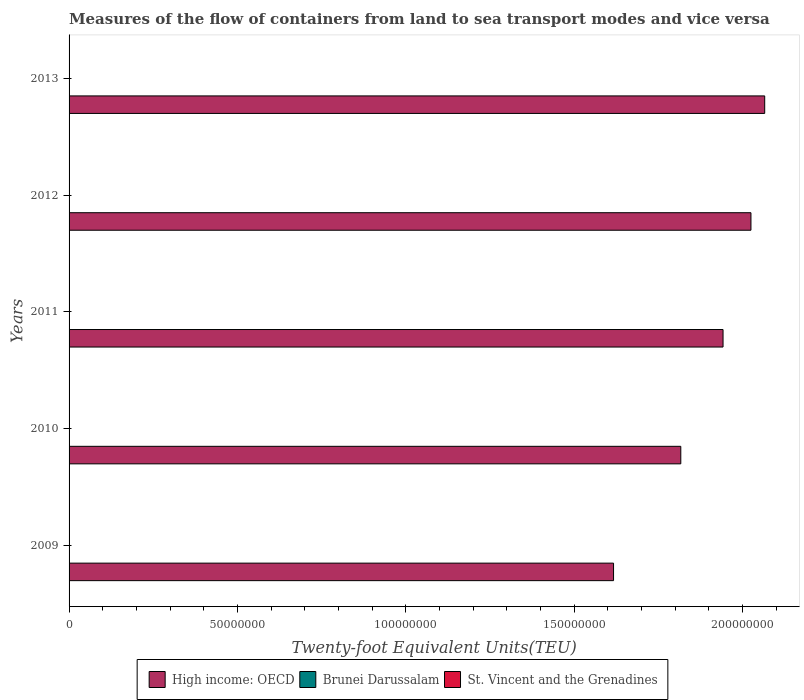How many different coloured bars are there?
Offer a terse response. 3. How many groups of bars are there?
Offer a terse response. 5. Are the number of bars per tick equal to the number of legend labels?
Make the answer very short. Yes. What is the label of the 4th group of bars from the top?
Your response must be concise. 2010. What is the container port traffic in Brunei Darussalam in 2009?
Provide a short and direct response. 8.56e+04. Across all years, what is the maximum container port traffic in St. Vincent and the Grenadines?
Offer a terse response. 2.31e+04. Across all years, what is the minimum container port traffic in High income: OECD?
Offer a very short reply. 1.62e+08. In which year was the container port traffic in St. Vincent and the Grenadines maximum?
Give a very brief answer. 2013. In which year was the container port traffic in High income: OECD minimum?
Offer a terse response. 2009. What is the total container port traffic in St. Vincent and the Grenadines in the graph?
Give a very brief answer. 9.96e+04. What is the difference between the container port traffic in St. Vincent and the Grenadines in 2009 and that in 2010?
Offer a terse response. -2614.32. What is the difference between the container port traffic in High income: OECD in 2010 and the container port traffic in Brunei Darussalam in 2011?
Provide a short and direct response. 1.82e+08. What is the average container port traffic in St. Vincent and the Grenadines per year?
Your answer should be compact. 1.99e+04. In the year 2009, what is the difference between the container port traffic in Brunei Darussalam and container port traffic in High income: OECD?
Offer a very short reply. -1.62e+08. In how many years, is the container port traffic in St. Vincent and the Grenadines greater than 30000000 TEU?
Provide a succinct answer. 0. What is the ratio of the container port traffic in High income: OECD in 2011 to that in 2013?
Keep it short and to the point. 0.94. What is the difference between the highest and the second highest container port traffic in High income: OECD?
Your response must be concise. 4.09e+06. What is the difference between the highest and the lowest container port traffic in St. Vincent and the Grenadines?
Your response must be concise. 6875.71. What does the 3rd bar from the top in 2013 represents?
Give a very brief answer. High income: OECD. What does the 2nd bar from the bottom in 2010 represents?
Keep it short and to the point. Brunei Darussalam. How many bars are there?
Offer a very short reply. 15. Are all the bars in the graph horizontal?
Offer a terse response. Yes. What is the difference between two consecutive major ticks on the X-axis?
Ensure brevity in your answer.  5.00e+07. Does the graph contain any zero values?
Provide a short and direct response. No. Where does the legend appear in the graph?
Provide a succinct answer. Bottom center. How many legend labels are there?
Make the answer very short. 3. How are the legend labels stacked?
Offer a terse response. Horizontal. What is the title of the graph?
Keep it short and to the point. Measures of the flow of containers from land to sea transport modes and vice versa. What is the label or title of the X-axis?
Provide a short and direct response. Twenty-foot Equivalent Units(TEU). What is the label or title of the Y-axis?
Your response must be concise. Years. What is the Twenty-foot Equivalent Units(TEU) in High income: OECD in 2009?
Make the answer very short. 1.62e+08. What is the Twenty-foot Equivalent Units(TEU) in Brunei Darussalam in 2009?
Give a very brief answer. 8.56e+04. What is the Twenty-foot Equivalent Units(TEU) in St. Vincent and the Grenadines in 2009?
Provide a short and direct response. 1.62e+04. What is the Twenty-foot Equivalent Units(TEU) of High income: OECD in 2010?
Offer a very short reply. 1.82e+08. What is the Twenty-foot Equivalent Units(TEU) in Brunei Darussalam in 2010?
Your answer should be compact. 9.94e+04. What is the Twenty-foot Equivalent Units(TEU) of St. Vincent and the Grenadines in 2010?
Provide a short and direct response. 1.89e+04. What is the Twenty-foot Equivalent Units(TEU) in High income: OECD in 2011?
Ensure brevity in your answer.  1.94e+08. What is the Twenty-foot Equivalent Units(TEU) in Brunei Darussalam in 2011?
Keep it short and to the point. 1.05e+05. What is the Twenty-foot Equivalent Units(TEU) in St. Vincent and the Grenadines in 2011?
Make the answer very short. 1.99e+04. What is the Twenty-foot Equivalent Units(TEU) in High income: OECD in 2012?
Make the answer very short. 2.03e+08. What is the Twenty-foot Equivalent Units(TEU) of Brunei Darussalam in 2012?
Ensure brevity in your answer.  1.13e+05. What is the Twenty-foot Equivalent Units(TEU) of St. Vincent and the Grenadines in 2012?
Give a very brief answer. 2.14e+04. What is the Twenty-foot Equivalent Units(TEU) in High income: OECD in 2013?
Make the answer very short. 2.07e+08. What is the Twenty-foot Equivalent Units(TEU) in Brunei Darussalam in 2013?
Your response must be concise. 1.22e+05. What is the Twenty-foot Equivalent Units(TEU) in St. Vincent and the Grenadines in 2013?
Ensure brevity in your answer.  2.31e+04. Across all years, what is the maximum Twenty-foot Equivalent Units(TEU) in High income: OECD?
Ensure brevity in your answer.  2.07e+08. Across all years, what is the maximum Twenty-foot Equivalent Units(TEU) in Brunei Darussalam?
Provide a short and direct response. 1.22e+05. Across all years, what is the maximum Twenty-foot Equivalent Units(TEU) of St. Vincent and the Grenadines?
Your response must be concise. 2.31e+04. Across all years, what is the minimum Twenty-foot Equivalent Units(TEU) in High income: OECD?
Offer a very short reply. 1.62e+08. Across all years, what is the minimum Twenty-foot Equivalent Units(TEU) of Brunei Darussalam?
Offer a very short reply. 8.56e+04. Across all years, what is the minimum Twenty-foot Equivalent Units(TEU) of St. Vincent and the Grenadines?
Keep it short and to the point. 1.62e+04. What is the total Twenty-foot Equivalent Units(TEU) of High income: OECD in the graph?
Your response must be concise. 9.47e+08. What is the total Twenty-foot Equivalent Units(TEU) of Brunei Darussalam in the graph?
Ensure brevity in your answer.  5.25e+05. What is the total Twenty-foot Equivalent Units(TEU) in St. Vincent and the Grenadines in the graph?
Offer a terse response. 9.96e+04. What is the difference between the Twenty-foot Equivalent Units(TEU) in High income: OECD in 2009 and that in 2010?
Offer a very short reply. -2.00e+07. What is the difference between the Twenty-foot Equivalent Units(TEU) of Brunei Darussalam in 2009 and that in 2010?
Make the answer very short. -1.38e+04. What is the difference between the Twenty-foot Equivalent Units(TEU) in St. Vincent and the Grenadines in 2009 and that in 2010?
Offer a very short reply. -2614.32. What is the difference between the Twenty-foot Equivalent Units(TEU) of High income: OECD in 2009 and that in 2011?
Your response must be concise. -3.25e+07. What is the difference between the Twenty-foot Equivalent Units(TEU) in Brunei Darussalam in 2009 and that in 2011?
Your response must be concise. -1.94e+04. What is the difference between the Twenty-foot Equivalent Units(TEU) in St. Vincent and the Grenadines in 2009 and that in 2011?
Ensure brevity in your answer.  -3688.9. What is the difference between the Twenty-foot Equivalent Units(TEU) of High income: OECD in 2009 and that in 2012?
Your answer should be compact. -4.08e+07. What is the difference between the Twenty-foot Equivalent Units(TEU) in Brunei Darussalam in 2009 and that in 2012?
Your answer should be compact. -2.73e+04. What is the difference between the Twenty-foot Equivalent Units(TEU) in St. Vincent and the Grenadines in 2009 and that in 2012?
Your answer should be compact. -5183.42. What is the difference between the Twenty-foot Equivalent Units(TEU) of High income: OECD in 2009 and that in 2013?
Give a very brief answer. -4.49e+07. What is the difference between the Twenty-foot Equivalent Units(TEU) of Brunei Darussalam in 2009 and that in 2013?
Ensure brevity in your answer.  -3.62e+04. What is the difference between the Twenty-foot Equivalent Units(TEU) of St. Vincent and the Grenadines in 2009 and that in 2013?
Keep it short and to the point. -6875.71. What is the difference between the Twenty-foot Equivalent Units(TEU) in High income: OECD in 2010 and that in 2011?
Your answer should be very brief. -1.25e+07. What is the difference between the Twenty-foot Equivalent Units(TEU) in Brunei Darussalam in 2010 and that in 2011?
Ensure brevity in your answer.  -5663.23. What is the difference between the Twenty-foot Equivalent Units(TEU) of St. Vincent and the Grenadines in 2010 and that in 2011?
Make the answer very short. -1074.58. What is the difference between the Twenty-foot Equivalent Units(TEU) in High income: OECD in 2010 and that in 2012?
Make the answer very short. -2.08e+07. What is the difference between the Twenty-foot Equivalent Units(TEU) in Brunei Darussalam in 2010 and that in 2012?
Your answer should be very brief. -1.35e+04. What is the difference between the Twenty-foot Equivalent Units(TEU) in St. Vincent and the Grenadines in 2010 and that in 2012?
Provide a short and direct response. -2569.1. What is the difference between the Twenty-foot Equivalent Units(TEU) in High income: OECD in 2010 and that in 2013?
Make the answer very short. -2.49e+07. What is the difference between the Twenty-foot Equivalent Units(TEU) in Brunei Darussalam in 2010 and that in 2013?
Your answer should be very brief. -2.25e+04. What is the difference between the Twenty-foot Equivalent Units(TEU) in St. Vincent and the Grenadines in 2010 and that in 2013?
Offer a very short reply. -4261.39. What is the difference between the Twenty-foot Equivalent Units(TEU) of High income: OECD in 2011 and that in 2012?
Ensure brevity in your answer.  -8.28e+06. What is the difference between the Twenty-foot Equivalent Units(TEU) in Brunei Darussalam in 2011 and that in 2012?
Provide a succinct answer. -7876.36. What is the difference between the Twenty-foot Equivalent Units(TEU) of St. Vincent and the Grenadines in 2011 and that in 2012?
Keep it short and to the point. -1494.52. What is the difference between the Twenty-foot Equivalent Units(TEU) of High income: OECD in 2011 and that in 2013?
Your response must be concise. -1.24e+07. What is the difference between the Twenty-foot Equivalent Units(TEU) in Brunei Darussalam in 2011 and that in 2013?
Ensure brevity in your answer.  -1.68e+04. What is the difference between the Twenty-foot Equivalent Units(TEU) in St. Vincent and the Grenadines in 2011 and that in 2013?
Ensure brevity in your answer.  -3186.81. What is the difference between the Twenty-foot Equivalent Units(TEU) of High income: OECD in 2012 and that in 2013?
Provide a short and direct response. -4.09e+06. What is the difference between the Twenty-foot Equivalent Units(TEU) of Brunei Darussalam in 2012 and that in 2013?
Give a very brief answer. -8918.66. What is the difference between the Twenty-foot Equivalent Units(TEU) in St. Vincent and the Grenadines in 2012 and that in 2013?
Offer a terse response. -1692.29. What is the difference between the Twenty-foot Equivalent Units(TEU) in High income: OECD in 2009 and the Twenty-foot Equivalent Units(TEU) in Brunei Darussalam in 2010?
Make the answer very short. 1.62e+08. What is the difference between the Twenty-foot Equivalent Units(TEU) in High income: OECD in 2009 and the Twenty-foot Equivalent Units(TEU) in St. Vincent and the Grenadines in 2010?
Offer a terse response. 1.62e+08. What is the difference between the Twenty-foot Equivalent Units(TEU) in Brunei Darussalam in 2009 and the Twenty-foot Equivalent Units(TEU) in St. Vincent and the Grenadines in 2010?
Your answer should be very brief. 6.67e+04. What is the difference between the Twenty-foot Equivalent Units(TEU) in High income: OECD in 2009 and the Twenty-foot Equivalent Units(TEU) in Brunei Darussalam in 2011?
Ensure brevity in your answer.  1.62e+08. What is the difference between the Twenty-foot Equivalent Units(TEU) in High income: OECD in 2009 and the Twenty-foot Equivalent Units(TEU) in St. Vincent and the Grenadines in 2011?
Ensure brevity in your answer.  1.62e+08. What is the difference between the Twenty-foot Equivalent Units(TEU) of Brunei Darussalam in 2009 and the Twenty-foot Equivalent Units(TEU) of St. Vincent and the Grenadines in 2011?
Keep it short and to the point. 6.57e+04. What is the difference between the Twenty-foot Equivalent Units(TEU) in High income: OECD in 2009 and the Twenty-foot Equivalent Units(TEU) in Brunei Darussalam in 2012?
Give a very brief answer. 1.62e+08. What is the difference between the Twenty-foot Equivalent Units(TEU) of High income: OECD in 2009 and the Twenty-foot Equivalent Units(TEU) of St. Vincent and the Grenadines in 2012?
Your response must be concise. 1.62e+08. What is the difference between the Twenty-foot Equivalent Units(TEU) in Brunei Darussalam in 2009 and the Twenty-foot Equivalent Units(TEU) in St. Vincent and the Grenadines in 2012?
Provide a succinct answer. 6.42e+04. What is the difference between the Twenty-foot Equivalent Units(TEU) in High income: OECD in 2009 and the Twenty-foot Equivalent Units(TEU) in Brunei Darussalam in 2013?
Offer a very short reply. 1.62e+08. What is the difference between the Twenty-foot Equivalent Units(TEU) in High income: OECD in 2009 and the Twenty-foot Equivalent Units(TEU) in St. Vincent and the Grenadines in 2013?
Ensure brevity in your answer.  1.62e+08. What is the difference between the Twenty-foot Equivalent Units(TEU) in Brunei Darussalam in 2009 and the Twenty-foot Equivalent Units(TEU) in St. Vincent and the Grenadines in 2013?
Ensure brevity in your answer.  6.25e+04. What is the difference between the Twenty-foot Equivalent Units(TEU) in High income: OECD in 2010 and the Twenty-foot Equivalent Units(TEU) in Brunei Darussalam in 2011?
Offer a very short reply. 1.82e+08. What is the difference between the Twenty-foot Equivalent Units(TEU) of High income: OECD in 2010 and the Twenty-foot Equivalent Units(TEU) of St. Vincent and the Grenadines in 2011?
Your answer should be compact. 1.82e+08. What is the difference between the Twenty-foot Equivalent Units(TEU) of Brunei Darussalam in 2010 and the Twenty-foot Equivalent Units(TEU) of St. Vincent and the Grenadines in 2011?
Provide a succinct answer. 7.94e+04. What is the difference between the Twenty-foot Equivalent Units(TEU) of High income: OECD in 2010 and the Twenty-foot Equivalent Units(TEU) of Brunei Darussalam in 2012?
Your answer should be very brief. 1.82e+08. What is the difference between the Twenty-foot Equivalent Units(TEU) in High income: OECD in 2010 and the Twenty-foot Equivalent Units(TEU) in St. Vincent and the Grenadines in 2012?
Ensure brevity in your answer.  1.82e+08. What is the difference between the Twenty-foot Equivalent Units(TEU) in Brunei Darussalam in 2010 and the Twenty-foot Equivalent Units(TEU) in St. Vincent and the Grenadines in 2012?
Make the answer very short. 7.79e+04. What is the difference between the Twenty-foot Equivalent Units(TEU) in High income: OECD in 2010 and the Twenty-foot Equivalent Units(TEU) in Brunei Darussalam in 2013?
Your answer should be very brief. 1.82e+08. What is the difference between the Twenty-foot Equivalent Units(TEU) in High income: OECD in 2010 and the Twenty-foot Equivalent Units(TEU) in St. Vincent and the Grenadines in 2013?
Keep it short and to the point. 1.82e+08. What is the difference between the Twenty-foot Equivalent Units(TEU) in Brunei Darussalam in 2010 and the Twenty-foot Equivalent Units(TEU) in St. Vincent and the Grenadines in 2013?
Provide a short and direct response. 7.62e+04. What is the difference between the Twenty-foot Equivalent Units(TEU) of High income: OECD in 2011 and the Twenty-foot Equivalent Units(TEU) of Brunei Darussalam in 2012?
Provide a succinct answer. 1.94e+08. What is the difference between the Twenty-foot Equivalent Units(TEU) of High income: OECD in 2011 and the Twenty-foot Equivalent Units(TEU) of St. Vincent and the Grenadines in 2012?
Offer a terse response. 1.94e+08. What is the difference between the Twenty-foot Equivalent Units(TEU) in Brunei Darussalam in 2011 and the Twenty-foot Equivalent Units(TEU) in St. Vincent and the Grenadines in 2012?
Make the answer very short. 8.36e+04. What is the difference between the Twenty-foot Equivalent Units(TEU) of High income: OECD in 2011 and the Twenty-foot Equivalent Units(TEU) of Brunei Darussalam in 2013?
Give a very brief answer. 1.94e+08. What is the difference between the Twenty-foot Equivalent Units(TEU) in High income: OECD in 2011 and the Twenty-foot Equivalent Units(TEU) in St. Vincent and the Grenadines in 2013?
Your answer should be very brief. 1.94e+08. What is the difference between the Twenty-foot Equivalent Units(TEU) in Brunei Darussalam in 2011 and the Twenty-foot Equivalent Units(TEU) in St. Vincent and the Grenadines in 2013?
Offer a terse response. 8.19e+04. What is the difference between the Twenty-foot Equivalent Units(TEU) of High income: OECD in 2012 and the Twenty-foot Equivalent Units(TEU) of Brunei Darussalam in 2013?
Offer a terse response. 2.02e+08. What is the difference between the Twenty-foot Equivalent Units(TEU) in High income: OECD in 2012 and the Twenty-foot Equivalent Units(TEU) in St. Vincent and the Grenadines in 2013?
Make the answer very short. 2.02e+08. What is the difference between the Twenty-foot Equivalent Units(TEU) in Brunei Darussalam in 2012 and the Twenty-foot Equivalent Units(TEU) in St. Vincent and the Grenadines in 2013?
Your answer should be very brief. 8.98e+04. What is the average Twenty-foot Equivalent Units(TEU) in High income: OECD per year?
Provide a succinct answer. 1.89e+08. What is the average Twenty-foot Equivalent Units(TEU) in Brunei Darussalam per year?
Ensure brevity in your answer.  1.05e+05. What is the average Twenty-foot Equivalent Units(TEU) in St. Vincent and the Grenadines per year?
Offer a very short reply. 1.99e+04. In the year 2009, what is the difference between the Twenty-foot Equivalent Units(TEU) of High income: OECD and Twenty-foot Equivalent Units(TEU) of Brunei Darussalam?
Your response must be concise. 1.62e+08. In the year 2009, what is the difference between the Twenty-foot Equivalent Units(TEU) of High income: OECD and Twenty-foot Equivalent Units(TEU) of St. Vincent and the Grenadines?
Ensure brevity in your answer.  1.62e+08. In the year 2009, what is the difference between the Twenty-foot Equivalent Units(TEU) in Brunei Darussalam and Twenty-foot Equivalent Units(TEU) in St. Vincent and the Grenadines?
Offer a terse response. 6.93e+04. In the year 2010, what is the difference between the Twenty-foot Equivalent Units(TEU) in High income: OECD and Twenty-foot Equivalent Units(TEU) in Brunei Darussalam?
Offer a very short reply. 1.82e+08. In the year 2010, what is the difference between the Twenty-foot Equivalent Units(TEU) in High income: OECD and Twenty-foot Equivalent Units(TEU) in St. Vincent and the Grenadines?
Your answer should be compact. 1.82e+08. In the year 2010, what is the difference between the Twenty-foot Equivalent Units(TEU) in Brunei Darussalam and Twenty-foot Equivalent Units(TEU) in St. Vincent and the Grenadines?
Offer a very short reply. 8.05e+04. In the year 2011, what is the difference between the Twenty-foot Equivalent Units(TEU) in High income: OECD and Twenty-foot Equivalent Units(TEU) in Brunei Darussalam?
Give a very brief answer. 1.94e+08. In the year 2011, what is the difference between the Twenty-foot Equivalent Units(TEU) of High income: OECD and Twenty-foot Equivalent Units(TEU) of St. Vincent and the Grenadines?
Offer a very short reply. 1.94e+08. In the year 2011, what is the difference between the Twenty-foot Equivalent Units(TEU) of Brunei Darussalam and Twenty-foot Equivalent Units(TEU) of St. Vincent and the Grenadines?
Offer a very short reply. 8.51e+04. In the year 2012, what is the difference between the Twenty-foot Equivalent Units(TEU) in High income: OECD and Twenty-foot Equivalent Units(TEU) in Brunei Darussalam?
Keep it short and to the point. 2.02e+08. In the year 2012, what is the difference between the Twenty-foot Equivalent Units(TEU) of High income: OECD and Twenty-foot Equivalent Units(TEU) of St. Vincent and the Grenadines?
Keep it short and to the point. 2.02e+08. In the year 2012, what is the difference between the Twenty-foot Equivalent Units(TEU) in Brunei Darussalam and Twenty-foot Equivalent Units(TEU) in St. Vincent and the Grenadines?
Make the answer very short. 9.15e+04. In the year 2013, what is the difference between the Twenty-foot Equivalent Units(TEU) in High income: OECD and Twenty-foot Equivalent Units(TEU) in Brunei Darussalam?
Ensure brevity in your answer.  2.06e+08. In the year 2013, what is the difference between the Twenty-foot Equivalent Units(TEU) in High income: OECD and Twenty-foot Equivalent Units(TEU) in St. Vincent and the Grenadines?
Offer a very short reply. 2.07e+08. In the year 2013, what is the difference between the Twenty-foot Equivalent Units(TEU) in Brunei Darussalam and Twenty-foot Equivalent Units(TEU) in St. Vincent and the Grenadines?
Offer a terse response. 9.87e+04. What is the ratio of the Twenty-foot Equivalent Units(TEU) of High income: OECD in 2009 to that in 2010?
Your response must be concise. 0.89. What is the ratio of the Twenty-foot Equivalent Units(TEU) in Brunei Darussalam in 2009 to that in 2010?
Ensure brevity in your answer.  0.86. What is the ratio of the Twenty-foot Equivalent Units(TEU) in St. Vincent and the Grenadines in 2009 to that in 2010?
Your answer should be very brief. 0.86. What is the ratio of the Twenty-foot Equivalent Units(TEU) of High income: OECD in 2009 to that in 2011?
Give a very brief answer. 0.83. What is the ratio of the Twenty-foot Equivalent Units(TEU) of Brunei Darussalam in 2009 to that in 2011?
Offer a terse response. 0.81. What is the ratio of the Twenty-foot Equivalent Units(TEU) of St. Vincent and the Grenadines in 2009 to that in 2011?
Your answer should be very brief. 0.81. What is the ratio of the Twenty-foot Equivalent Units(TEU) of High income: OECD in 2009 to that in 2012?
Your answer should be compact. 0.8. What is the ratio of the Twenty-foot Equivalent Units(TEU) of Brunei Darussalam in 2009 to that in 2012?
Provide a succinct answer. 0.76. What is the ratio of the Twenty-foot Equivalent Units(TEU) in St. Vincent and the Grenadines in 2009 to that in 2012?
Your answer should be compact. 0.76. What is the ratio of the Twenty-foot Equivalent Units(TEU) in High income: OECD in 2009 to that in 2013?
Your answer should be compact. 0.78. What is the ratio of the Twenty-foot Equivalent Units(TEU) of Brunei Darussalam in 2009 to that in 2013?
Make the answer very short. 0.7. What is the ratio of the Twenty-foot Equivalent Units(TEU) in St. Vincent and the Grenadines in 2009 to that in 2013?
Offer a very short reply. 0.7. What is the ratio of the Twenty-foot Equivalent Units(TEU) in High income: OECD in 2010 to that in 2011?
Keep it short and to the point. 0.94. What is the ratio of the Twenty-foot Equivalent Units(TEU) in Brunei Darussalam in 2010 to that in 2011?
Your answer should be very brief. 0.95. What is the ratio of the Twenty-foot Equivalent Units(TEU) of St. Vincent and the Grenadines in 2010 to that in 2011?
Offer a very short reply. 0.95. What is the ratio of the Twenty-foot Equivalent Units(TEU) in High income: OECD in 2010 to that in 2012?
Offer a very short reply. 0.9. What is the ratio of the Twenty-foot Equivalent Units(TEU) in Brunei Darussalam in 2010 to that in 2012?
Ensure brevity in your answer.  0.88. What is the ratio of the Twenty-foot Equivalent Units(TEU) of St. Vincent and the Grenadines in 2010 to that in 2012?
Provide a short and direct response. 0.88. What is the ratio of the Twenty-foot Equivalent Units(TEU) of High income: OECD in 2010 to that in 2013?
Your answer should be compact. 0.88. What is the ratio of the Twenty-foot Equivalent Units(TEU) of Brunei Darussalam in 2010 to that in 2013?
Ensure brevity in your answer.  0.82. What is the ratio of the Twenty-foot Equivalent Units(TEU) in St. Vincent and the Grenadines in 2010 to that in 2013?
Your answer should be very brief. 0.82. What is the ratio of the Twenty-foot Equivalent Units(TEU) in High income: OECD in 2011 to that in 2012?
Your answer should be compact. 0.96. What is the ratio of the Twenty-foot Equivalent Units(TEU) in Brunei Darussalam in 2011 to that in 2012?
Offer a terse response. 0.93. What is the ratio of the Twenty-foot Equivalent Units(TEU) of St. Vincent and the Grenadines in 2011 to that in 2012?
Offer a very short reply. 0.93. What is the ratio of the Twenty-foot Equivalent Units(TEU) of High income: OECD in 2011 to that in 2013?
Provide a succinct answer. 0.94. What is the ratio of the Twenty-foot Equivalent Units(TEU) of Brunei Darussalam in 2011 to that in 2013?
Ensure brevity in your answer.  0.86. What is the ratio of the Twenty-foot Equivalent Units(TEU) in St. Vincent and the Grenadines in 2011 to that in 2013?
Offer a terse response. 0.86. What is the ratio of the Twenty-foot Equivalent Units(TEU) in High income: OECD in 2012 to that in 2013?
Offer a terse response. 0.98. What is the ratio of the Twenty-foot Equivalent Units(TEU) in Brunei Darussalam in 2012 to that in 2013?
Provide a short and direct response. 0.93. What is the ratio of the Twenty-foot Equivalent Units(TEU) in St. Vincent and the Grenadines in 2012 to that in 2013?
Give a very brief answer. 0.93. What is the difference between the highest and the second highest Twenty-foot Equivalent Units(TEU) of High income: OECD?
Provide a short and direct response. 4.09e+06. What is the difference between the highest and the second highest Twenty-foot Equivalent Units(TEU) of Brunei Darussalam?
Give a very brief answer. 8918.66. What is the difference between the highest and the second highest Twenty-foot Equivalent Units(TEU) in St. Vincent and the Grenadines?
Your response must be concise. 1692.29. What is the difference between the highest and the lowest Twenty-foot Equivalent Units(TEU) in High income: OECD?
Keep it short and to the point. 4.49e+07. What is the difference between the highest and the lowest Twenty-foot Equivalent Units(TEU) in Brunei Darussalam?
Ensure brevity in your answer.  3.62e+04. What is the difference between the highest and the lowest Twenty-foot Equivalent Units(TEU) in St. Vincent and the Grenadines?
Provide a short and direct response. 6875.71. 